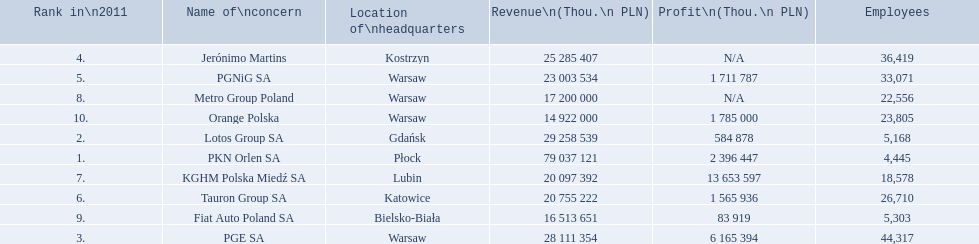What company has 28 111 354 thou.in revenue? PGE SA. Parse the full table. {'header': ['Rank in\\n2011', 'Name of\\nconcern', 'Location of\\nheadquarters', 'Revenue\\n(Thou.\\n\xa0PLN)', 'Profit\\n(Thou.\\n\xa0PLN)', 'Employees'], 'rows': [['4.', 'Jerónimo Martins', 'Kostrzyn', '25 285 407', 'N/A', '36,419'], ['5.', 'PGNiG SA', 'Warsaw', '23 003 534', '1 711 787', '33,071'], ['8.', 'Metro Group Poland', 'Warsaw', '17 200 000', 'N/A', '22,556'], ['10.', 'Orange Polska', 'Warsaw', '14 922 000', '1 785 000', '23,805'], ['2.', 'Lotos Group SA', 'Gdańsk', '29 258 539', '584 878', '5,168'], ['1.', 'PKN Orlen SA', 'Płock', '79 037 121', '2 396 447', '4,445'], ['7.', 'KGHM Polska Miedź SA', 'Lubin', '20 097 392', '13 653 597', '18,578'], ['6.', 'Tauron Group SA', 'Katowice', '20 755 222', '1 565 936', '26,710'], ['9.', 'Fiat Auto Poland SA', 'Bielsko-Biała', '16 513 651', '83 919', '5,303'], ['3.', 'PGE SA', 'Warsaw', '28 111 354', '6 165 394', '44,317']]} What revenue does lotus group sa have? 29 258 539. Who has the next highest revenue than lotus group sa? PKN Orlen SA. 